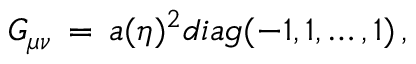Convert formula to latex. <formula><loc_0><loc_0><loc_500><loc_500>G _ { \mu \nu } \, = \, a ( \eta ) ^ { 2 } d i a g ( - 1 , 1 , \dots , 1 ) \, ,</formula> 